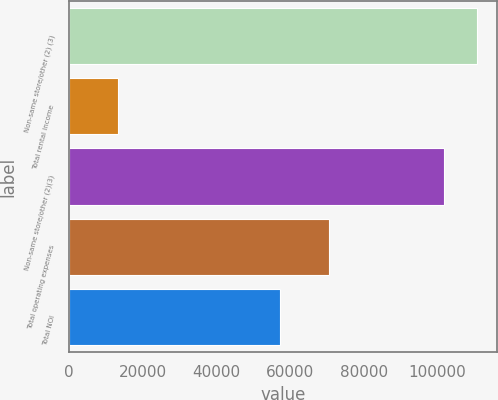Convert chart to OTSL. <chart><loc_0><loc_0><loc_500><loc_500><bar_chart><fcel>Non-same store/other (2) (3)<fcel>Total rental income<fcel>Non-same store/other (2)(3)<fcel>Total operating expenses<fcel>Total NOI<nl><fcel>110610<fcel>13253<fcel>101742<fcel>70537<fcel>57284<nl></chart> 